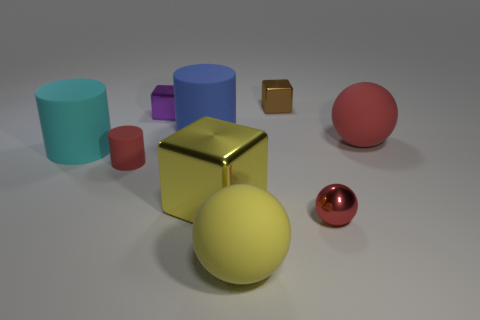Is the size of the rubber ball to the right of the yellow matte thing the same as the red cylinder?
Ensure brevity in your answer.  No. Is the number of big shiny cubes that are left of the yellow shiny block less than the number of yellow objects that are behind the large cyan cylinder?
Provide a succinct answer. No. Do the large cube and the tiny matte object have the same color?
Your answer should be very brief. No. Is the number of metal blocks behind the purple object less than the number of red cubes?
Make the answer very short. No. There is a large object that is the same color as the big cube; what is its material?
Your answer should be very brief. Rubber. Do the big blue thing and the brown block have the same material?
Offer a very short reply. No. What number of big yellow cubes are the same material as the tiny brown block?
Ensure brevity in your answer.  1. There is another big sphere that is made of the same material as the big yellow ball; what is its color?
Offer a terse response. Red. The big red object is what shape?
Your answer should be very brief. Sphere. There is a small brown object that is behind the big yellow rubber thing; what material is it?
Make the answer very short. Metal. 